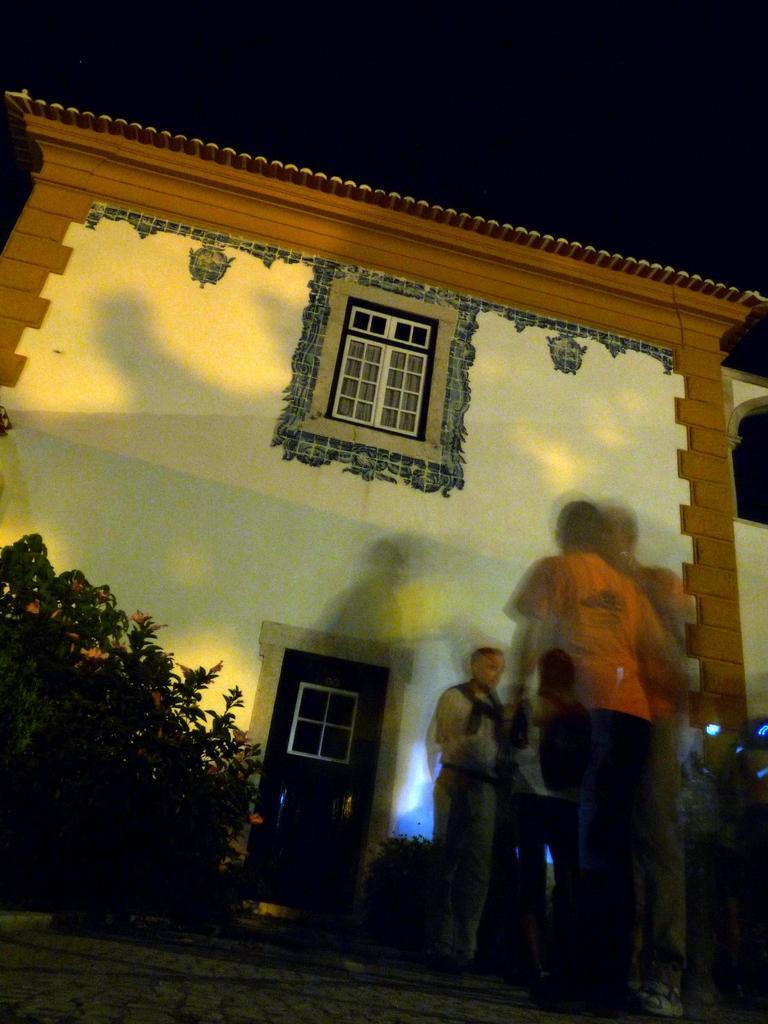Describe this image in one or two sentences. In this image I can see a building and in the front of it I can see few people are standing. I can also see a plant on the left side of this image and on the right side I can see few lights. 